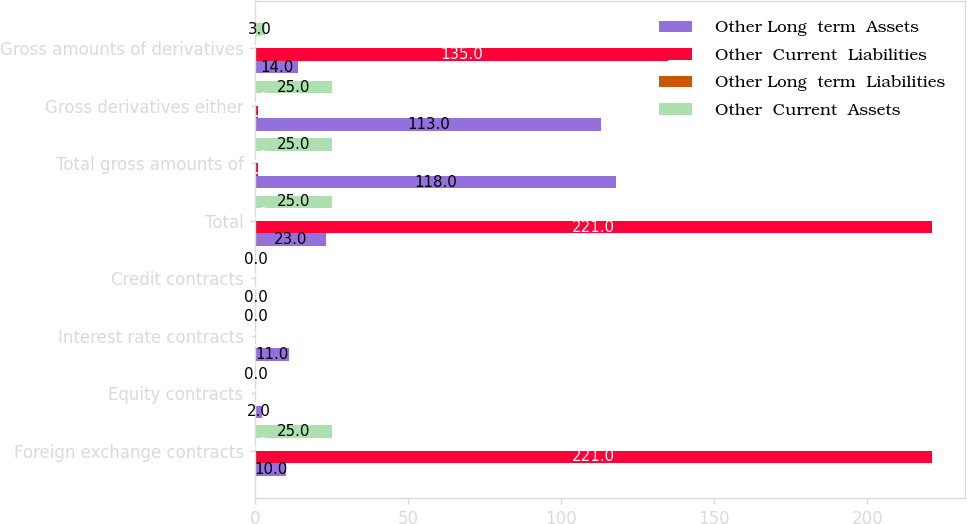Convert chart to OTSL. <chart><loc_0><loc_0><loc_500><loc_500><stacked_bar_chart><ecel><fcel>Foreign exchange contracts<fcel>Equity contracts<fcel>Interest rate contracts<fcel>Credit contracts<fcel>Total<fcel>Total gross amounts of<fcel>Gross derivatives either<fcel>Gross amounts of derivatives<nl><fcel>Other Long  term  Assets<fcel>10<fcel>2<fcel>11<fcel>0<fcel>23<fcel>118<fcel>113<fcel>14<nl><fcel>Other  Current  Liabilities<fcel>221<fcel>0<fcel>0<fcel>0<fcel>221<fcel>1<fcel>1<fcel>135<nl><fcel>Other Long  term  Liabilities<fcel>0<fcel>0<fcel>0<fcel>0<fcel>0<fcel>0<fcel>0<fcel>0<nl><fcel>Other  Current  Assets<fcel>25<fcel>0<fcel>0<fcel>0<fcel>25<fcel>25<fcel>25<fcel>3<nl></chart> 